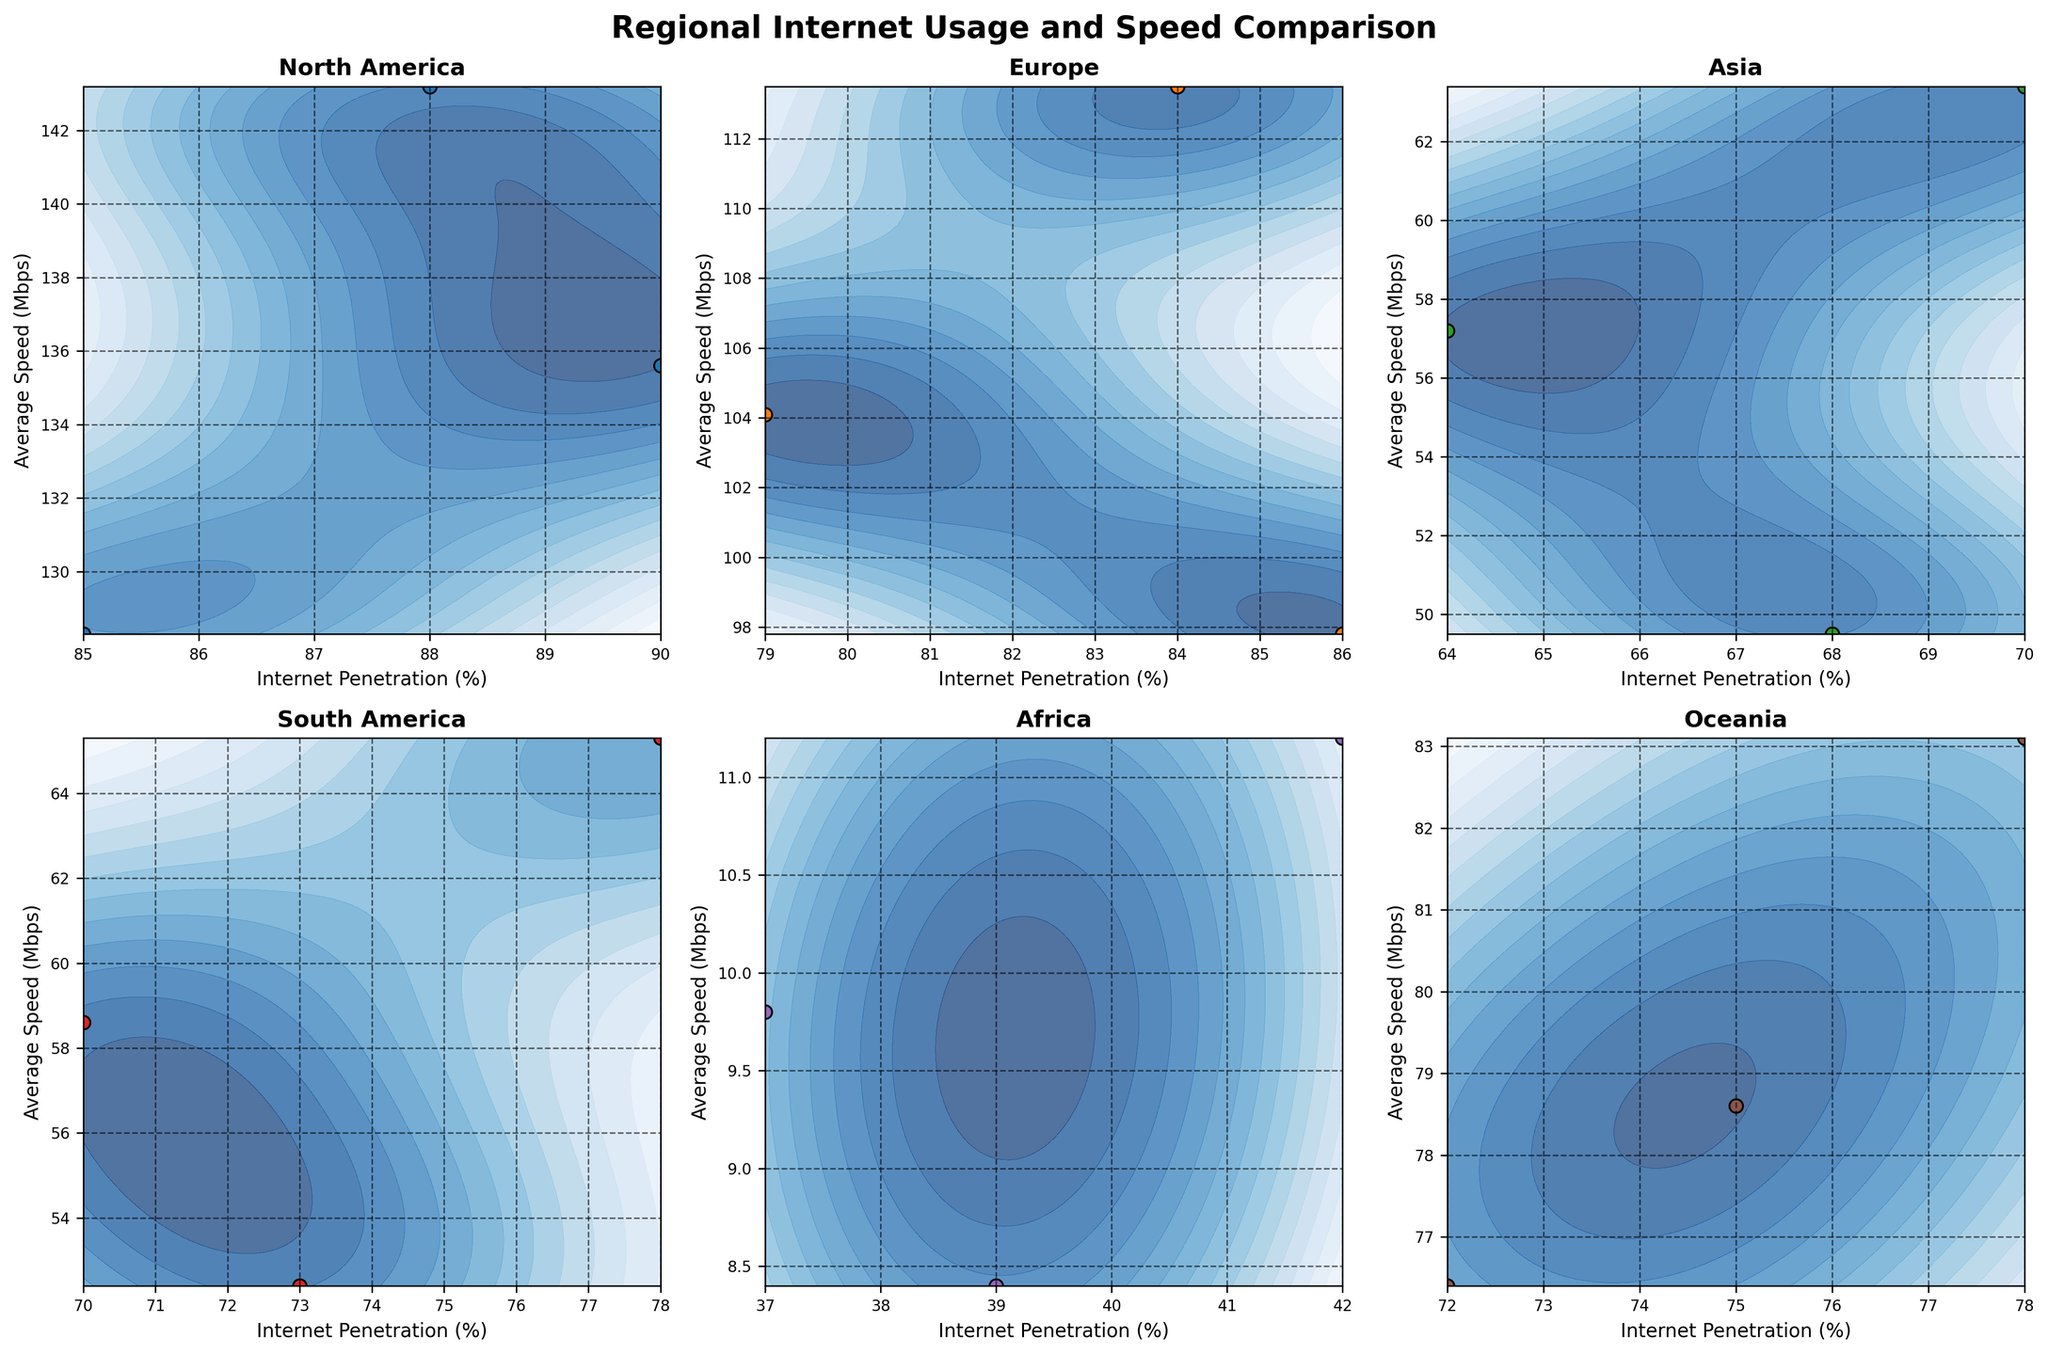How many regions are represented in the figure? By counting the titles of the subplots, we can see that there are six regions: North America, Europe, Asia, South America, Africa, and Oceania.
Answer: 6 What is the title of the figure? The title of the figure is located at the top of the subplot and reads "Regional Internet Usage and Speed Comparison."
Answer: Regional Internet Usage and Speed Comparison Which region appears to have the highest average connection speed in its data points? Looking at the subplots, North America has data points that reach up to around 143.2 Mbps, which is higher than any other region.
Answer: North America For the region with the lowest internet penetration percentage, what is the approximate range of average connection speeds? In the Africa subplot, the internet penetration percentages range from 37% to 42%, and the average speeds range from about 8.4 Mbps to 11.2 Mbps.
Answer: 8.4 Mbps to 11.2 Mbps Which region has data points closer to each other in terms of both internet penetration and average connection speed? The Oceania subplot shows data points that are relatively close together with internet penetration percentages from 72% to 78% and speeds from 76.4 Mbps to 83.1 Mbps.
Answer: Oceania How does the average speed in Asia compare to that in South America? By looking at the data points, Asia’s average speeds range from 49.5 Mbps to 63.4 Mbps, whereas South America's range from 52.4 Mbps to 65.3 Mbps, making both regions have similar ranges but with slightly higher upper values in South America.
Answer: South America is slightly higher In which region is the difference between the highest and lowest internet penetration percentages the smallest? Oceania’s internet penetration percentages range from 72% to 78%, a difference of 6%, which is smaller than any other region.
Answer: Oceania Which subplot contains data points where the internet penetration percentage is below 50%? Africa is the only region with internet penetration percentages below 50%, as seen in the subplot with percentages ranging from 37% to 42%.
Answer: Africa Which region has the widest range of average connection speeds in its data points? North America’s average speeds range from 128.3 Mbps to 143.2 Mbps, a range of 14.9 Mbps, which is wider than the ranges observed in other regions.
Answer: North America 